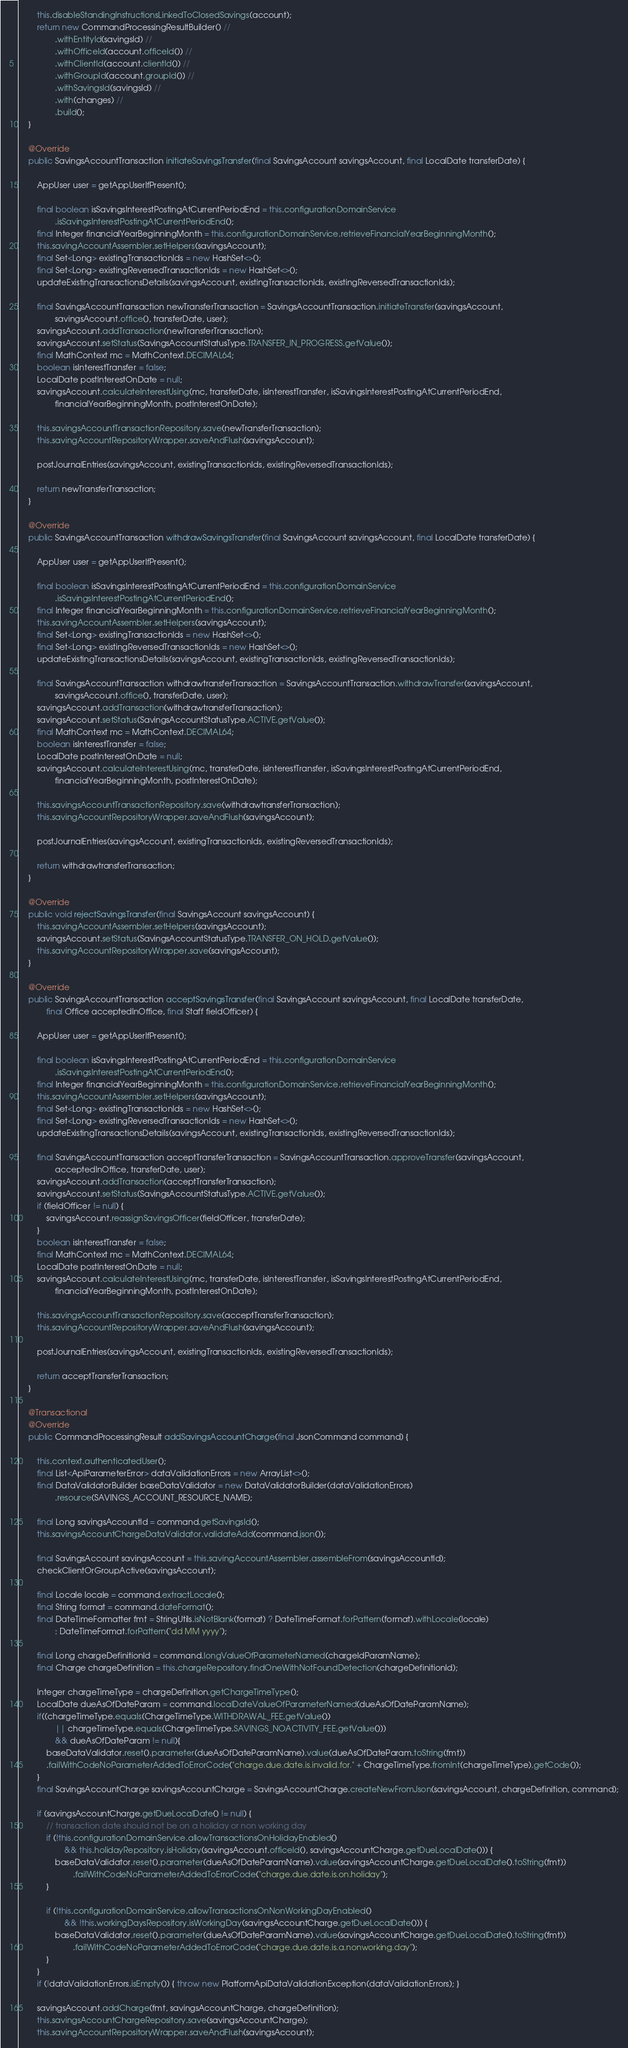Convert code to text. <code><loc_0><loc_0><loc_500><loc_500><_Java_>        this.disableStandingInstructionsLinkedToClosedSavings(account);
        return new CommandProcessingResultBuilder() //
                .withEntityId(savingsId) //
                .withOfficeId(account.officeId()) //
                .withClientId(account.clientId()) //
                .withGroupId(account.groupId()) //
                .withSavingsId(savingsId) //
                .with(changes) //
                .build();
    }

    @Override
    public SavingsAccountTransaction initiateSavingsTransfer(final SavingsAccount savingsAccount, final LocalDate transferDate) {

        AppUser user = getAppUserIfPresent();

        final boolean isSavingsInterestPostingAtCurrentPeriodEnd = this.configurationDomainService
                .isSavingsInterestPostingAtCurrentPeriodEnd();
        final Integer financialYearBeginningMonth = this.configurationDomainService.retrieveFinancialYearBeginningMonth();
        this.savingAccountAssembler.setHelpers(savingsAccount);
        final Set<Long> existingTransactionIds = new HashSet<>();
        final Set<Long> existingReversedTransactionIds = new HashSet<>();
        updateExistingTransactionsDetails(savingsAccount, existingTransactionIds, existingReversedTransactionIds);

        final SavingsAccountTransaction newTransferTransaction = SavingsAccountTransaction.initiateTransfer(savingsAccount,
                savingsAccount.office(), transferDate, user);
        savingsAccount.addTransaction(newTransferTransaction);
        savingsAccount.setStatus(SavingsAccountStatusType.TRANSFER_IN_PROGRESS.getValue());
        final MathContext mc = MathContext.DECIMAL64;
        boolean isInterestTransfer = false;
        LocalDate postInterestOnDate = null;
        savingsAccount.calculateInterestUsing(mc, transferDate, isInterestTransfer, isSavingsInterestPostingAtCurrentPeriodEnd,
                financialYearBeginningMonth, postInterestOnDate);

        this.savingsAccountTransactionRepository.save(newTransferTransaction);
        this.savingAccountRepositoryWrapper.saveAndFlush(savingsAccount);

        postJournalEntries(savingsAccount, existingTransactionIds, existingReversedTransactionIds);

        return newTransferTransaction;
    }

    @Override
    public SavingsAccountTransaction withdrawSavingsTransfer(final SavingsAccount savingsAccount, final LocalDate transferDate) {

        AppUser user = getAppUserIfPresent();

        final boolean isSavingsInterestPostingAtCurrentPeriodEnd = this.configurationDomainService
                .isSavingsInterestPostingAtCurrentPeriodEnd();
        final Integer financialYearBeginningMonth = this.configurationDomainService.retrieveFinancialYearBeginningMonth();
        this.savingAccountAssembler.setHelpers(savingsAccount);
        final Set<Long> existingTransactionIds = new HashSet<>();
        final Set<Long> existingReversedTransactionIds = new HashSet<>();
        updateExistingTransactionsDetails(savingsAccount, existingTransactionIds, existingReversedTransactionIds);

        final SavingsAccountTransaction withdrawtransferTransaction = SavingsAccountTransaction.withdrawTransfer(savingsAccount,
                savingsAccount.office(), transferDate, user);
        savingsAccount.addTransaction(withdrawtransferTransaction);
        savingsAccount.setStatus(SavingsAccountStatusType.ACTIVE.getValue());
        final MathContext mc = MathContext.DECIMAL64;
        boolean isInterestTransfer = false;
        LocalDate postInterestOnDate = null;
        savingsAccount.calculateInterestUsing(mc, transferDate, isInterestTransfer, isSavingsInterestPostingAtCurrentPeriodEnd,
                financialYearBeginningMonth, postInterestOnDate);

        this.savingsAccountTransactionRepository.save(withdrawtransferTransaction);
        this.savingAccountRepositoryWrapper.saveAndFlush(savingsAccount);

        postJournalEntries(savingsAccount, existingTransactionIds, existingReversedTransactionIds);

        return withdrawtransferTransaction;
    }

    @Override
    public void rejectSavingsTransfer(final SavingsAccount savingsAccount) {
        this.savingAccountAssembler.setHelpers(savingsAccount);
        savingsAccount.setStatus(SavingsAccountStatusType.TRANSFER_ON_HOLD.getValue());
        this.savingAccountRepositoryWrapper.save(savingsAccount);
    }

    @Override
    public SavingsAccountTransaction acceptSavingsTransfer(final SavingsAccount savingsAccount, final LocalDate transferDate,
            final Office acceptedInOffice, final Staff fieldOfficer) {

        AppUser user = getAppUserIfPresent();

        final boolean isSavingsInterestPostingAtCurrentPeriodEnd = this.configurationDomainService
                .isSavingsInterestPostingAtCurrentPeriodEnd();
        final Integer financialYearBeginningMonth = this.configurationDomainService.retrieveFinancialYearBeginningMonth();
        this.savingAccountAssembler.setHelpers(savingsAccount);
        final Set<Long> existingTransactionIds = new HashSet<>();
        final Set<Long> existingReversedTransactionIds = new HashSet<>();
        updateExistingTransactionsDetails(savingsAccount, existingTransactionIds, existingReversedTransactionIds);

        final SavingsAccountTransaction acceptTransferTransaction = SavingsAccountTransaction.approveTransfer(savingsAccount,
                acceptedInOffice, transferDate, user);
        savingsAccount.addTransaction(acceptTransferTransaction);
        savingsAccount.setStatus(SavingsAccountStatusType.ACTIVE.getValue());
        if (fieldOfficer != null) {
            savingsAccount.reassignSavingsOfficer(fieldOfficer, transferDate);
        }
        boolean isInterestTransfer = false;
        final MathContext mc = MathContext.DECIMAL64;
        LocalDate postInterestOnDate = null;
        savingsAccount.calculateInterestUsing(mc, transferDate, isInterestTransfer, isSavingsInterestPostingAtCurrentPeriodEnd,
                financialYearBeginningMonth, postInterestOnDate);

        this.savingsAccountTransactionRepository.save(acceptTransferTransaction);
        this.savingAccountRepositoryWrapper.saveAndFlush(savingsAccount);

        postJournalEntries(savingsAccount, existingTransactionIds, existingReversedTransactionIds);

        return acceptTransferTransaction;
    }

    @Transactional
    @Override
    public CommandProcessingResult addSavingsAccountCharge(final JsonCommand command) {

        this.context.authenticatedUser();
        final List<ApiParameterError> dataValidationErrors = new ArrayList<>();
        final DataValidatorBuilder baseDataValidator = new DataValidatorBuilder(dataValidationErrors)
                .resource(SAVINGS_ACCOUNT_RESOURCE_NAME);

        final Long savingsAccountId = command.getSavingsId();
        this.savingsAccountChargeDataValidator.validateAdd(command.json());

        final SavingsAccount savingsAccount = this.savingAccountAssembler.assembleFrom(savingsAccountId);
        checkClientOrGroupActive(savingsAccount);

        final Locale locale = command.extractLocale();
        final String format = command.dateFormat();
        final DateTimeFormatter fmt = StringUtils.isNotBlank(format) ? DateTimeFormat.forPattern(format).withLocale(locale)
                : DateTimeFormat.forPattern("dd MM yyyy");

        final Long chargeDefinitionId = command.longValueOfParameterNamed(chargeIdParamName);
        final Charge chargeDefinition = this.chargeRepository.findOneWithNotFoundDetection(chargeDefinitionId);

        Integer chargeTimeType = chargeDefinition.getChargeTimeType();
        LocalDate dueAsOfDateParam = command.localDateValueOfParameterNamed(dueAsOfDateParamName);
        if((chargeTimeType.equals(ChargeTimeType.WITHDRAWAL_FEE.getValue())
        		|| chargeTimeType.equals(ChargeTimeType.SAVINGS_NOACTIVITY_FEE.getValue()))
        		&& dueAsOfDateParam != null){
            baseDataValidator.reset().parameter(dueAsOfDateParamName).value(dueAsOfDateParam.toString(fmt))
            .failWithCodeNoParameterAddedToErrorCode("charge.due.date.is.invalid.for." + ChargeTimeType.fromInt(chargeTimeType).getCode());
        }
        final SavingsAccountCharge savingsAccountCharge = SavingsAccountCharge.createNewFromJson(savingsAccount, chargeDefinition, command);

        if (savingsAccountCharge.getDueLocalDate() != null) {
            // transaction date should not be on a holiday or non working day
            if (!this.configurationDomainService.allowTransactionsOnHolidayEnabled()
                    && this.holidayRepository.isHoliday(savingsAccount.officeId(), savingsAccountCharge.getDueLocalDate())) {
                baseDataValidator.reset().parameter(dueAsOfDateParamName).value(savingsAccountCharge.getDueLocalDate().toString(fmt))
                        .failWithCodeNoParameterAddedToErrorCode("charge.due.date.is.on.holiday");
            }

            if (!this.configurationDomainService.allowTransactionsOnNonWorkingDayEnabled()
                    && !this.workingDaysRepository.isWorkingDay(savingsAccountCharge.getDueLocalDate())) {
                baseDataValidator.reset().parameter(dueAsOfDateParamName).value(savingsAccountCharge.getDueLocalDate().toString(fmt))
                        .failWithCodeNoParameterAddedToErrorCode("charge.due.date.is.a.nonworking.day");
            }
        }
        if (!dataValidationErrors.isEmpty()) { throw new PlatformApiDataValidationException(dataValidationErrors); }

        savingsAccount.addCharge(fmt, savingsAccountCharge, chargeDefinition);
        this.savingsAccountChargeRepository.save(savingsAccountCharge);
        this.savingAccountRepositoryWrapper.saveAndFlush(savingsAccount);</code> 